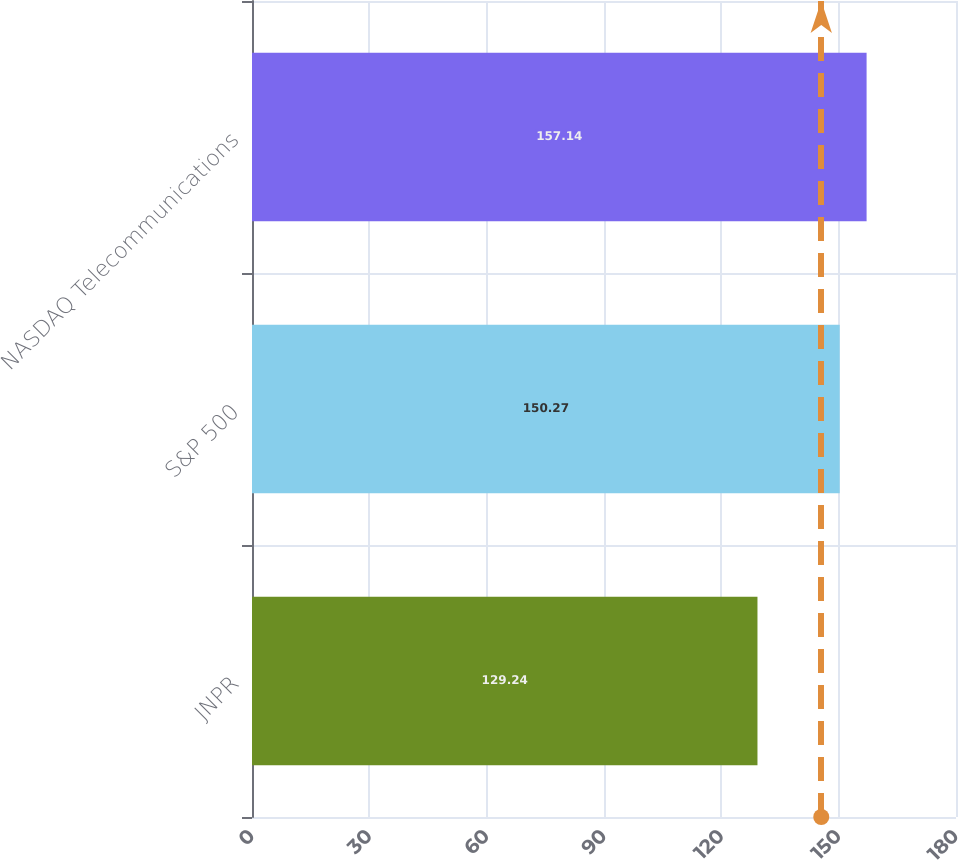<chart> <loc_0><loc_0><loc_500><loc_500><bar_chart><fcel>JNPR<fcel>S&P 500<fcel>NASDAQ Telecommunications<nl><fcel>129.24<fcel>150.27<fcel>157.14<nl></chart> 